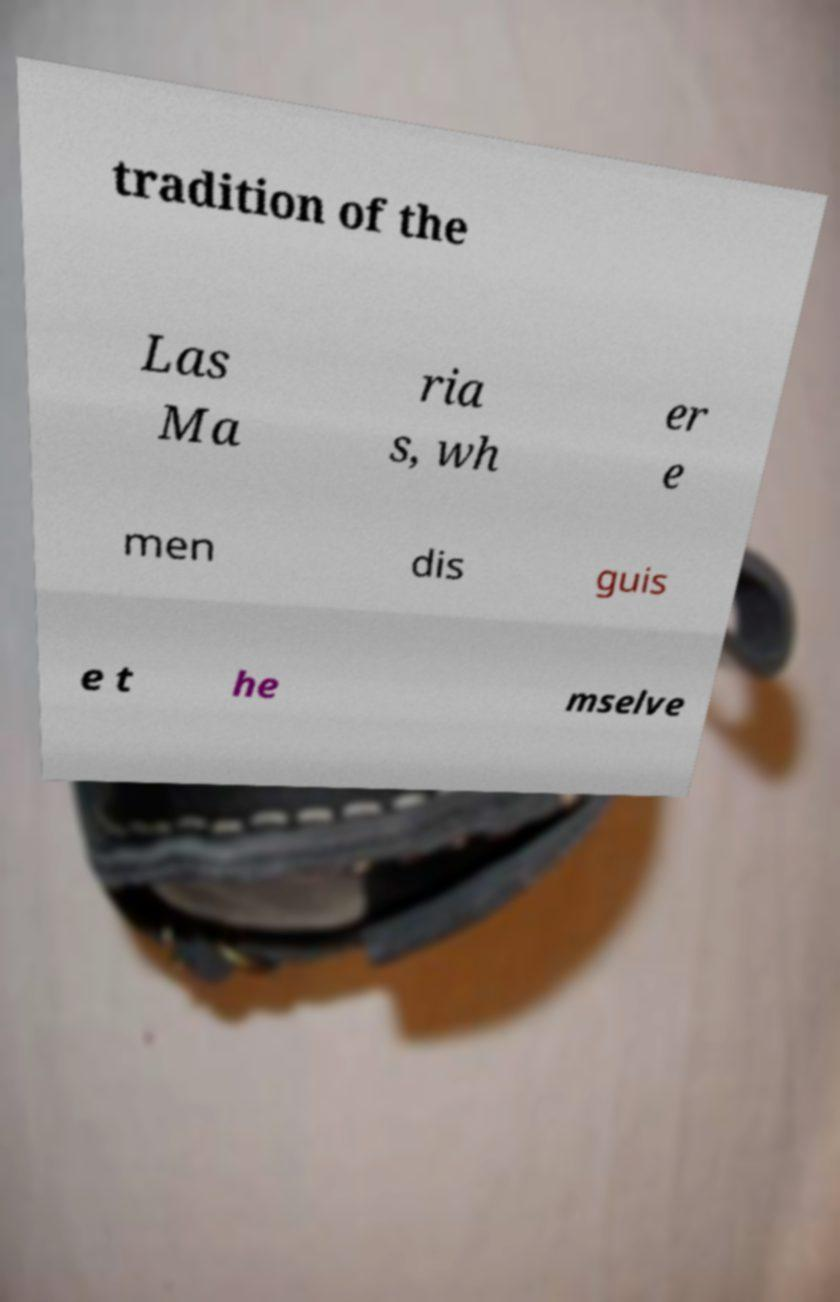What messages or text are displayed in this image? I need them in a readable, typed format. tradition of the Las Ma ria s, wh er e men dis guis e t he mselve 